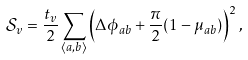Convert formula to latex. <formula><loc_0><loc_0><loc_500><loc_500>\mathcal { S } _ { v } = \frac { t _ { v } } { 2 } \sum _ { \langle a , b \rangle } \left ( \Delta \phi _ { a b } + \frac { \pi } { 2 } ( 1 - \mu _ { a b } ) \right ) ^ { 2 } ,</formula> 